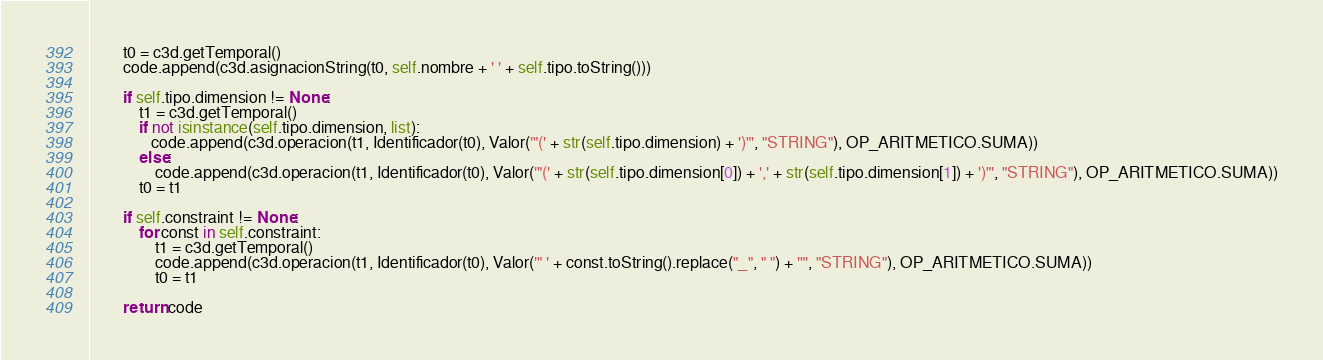<code> <loc_0><loc_0><loc_500><loc_500><_Python_>        t0 = c3d.getTemporal()
        code.append(c3d.asignacionString(t0, self.nombre + ' ' + self.tipo.toString()))
        
        if self.tipo.dimension != None:
            t1 = c3d.getTemporal()
            if not isinstance(self.tipo.dimension, list):
               code.append(c3d.operacion(t1, Identificador(t0), Valor('"(' + str(self.tipo.dimension) + ')"', "STRING"), OP_ARITMETICO.SUMA))
            else:
                code.append(c3d.operacion(t1, Identificador(t0), Valor('"(' + str(self.tipo.dimension[0]) + ',' + str(self.tipo.dimension[1]) + ')"', "STRING"), OP_ARITMETICO.SUMA))
            t0 = t1

        if self.constraint != None:
            for const in self.constraint:
                t1 = c3d.getTemporal()
                code.append(c3d.operacion(t1, Identificador(t0), Valor('" ' + const.toString().replace("_", " ") + '"', "STRING"), OP_ARITMETICO.SUMA))
                t0 = t1

        return code
</code> 